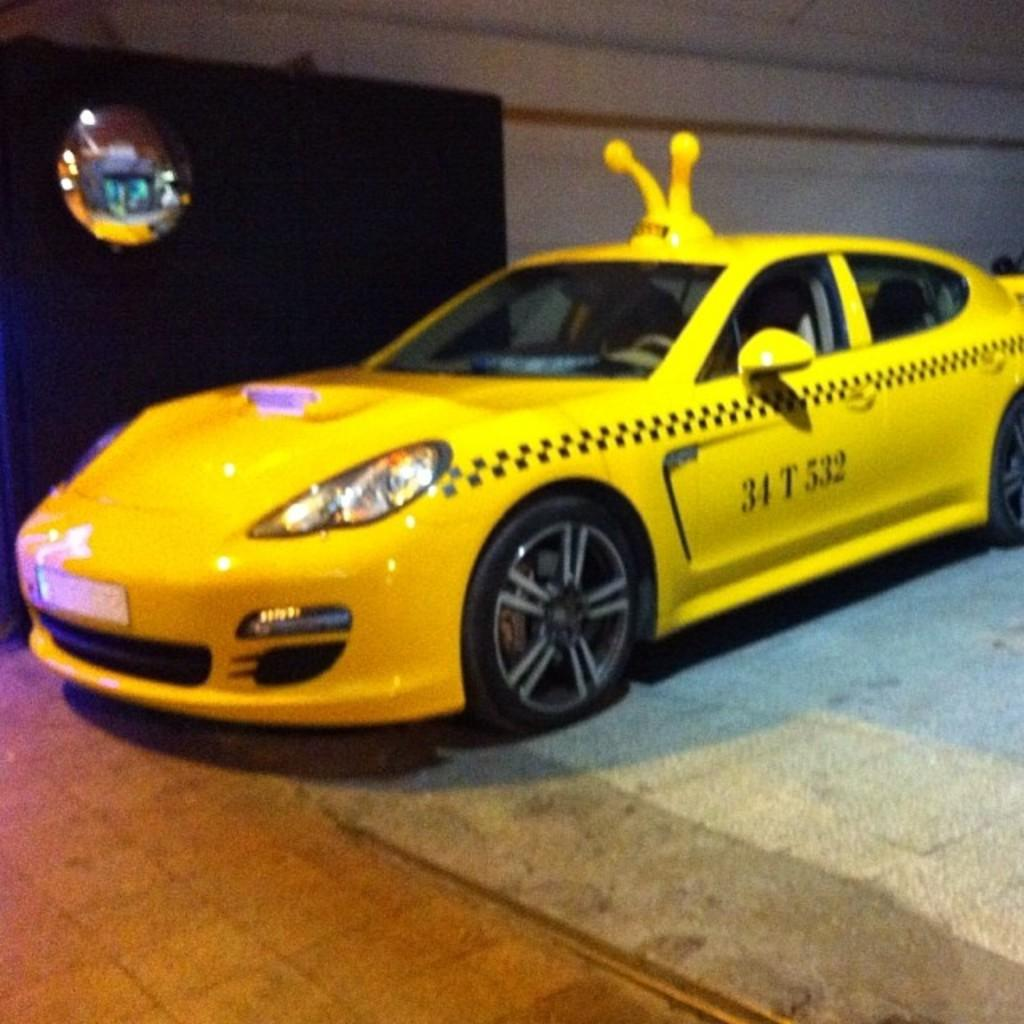<image>
Render a clear and concise summary of the photo. The yellow car shown has the numbers and letters on the side of 34 T 532. 